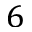Convert formula to latex. <formula><loc_0><loc_0><loc_500><loc_500>6</formula> 